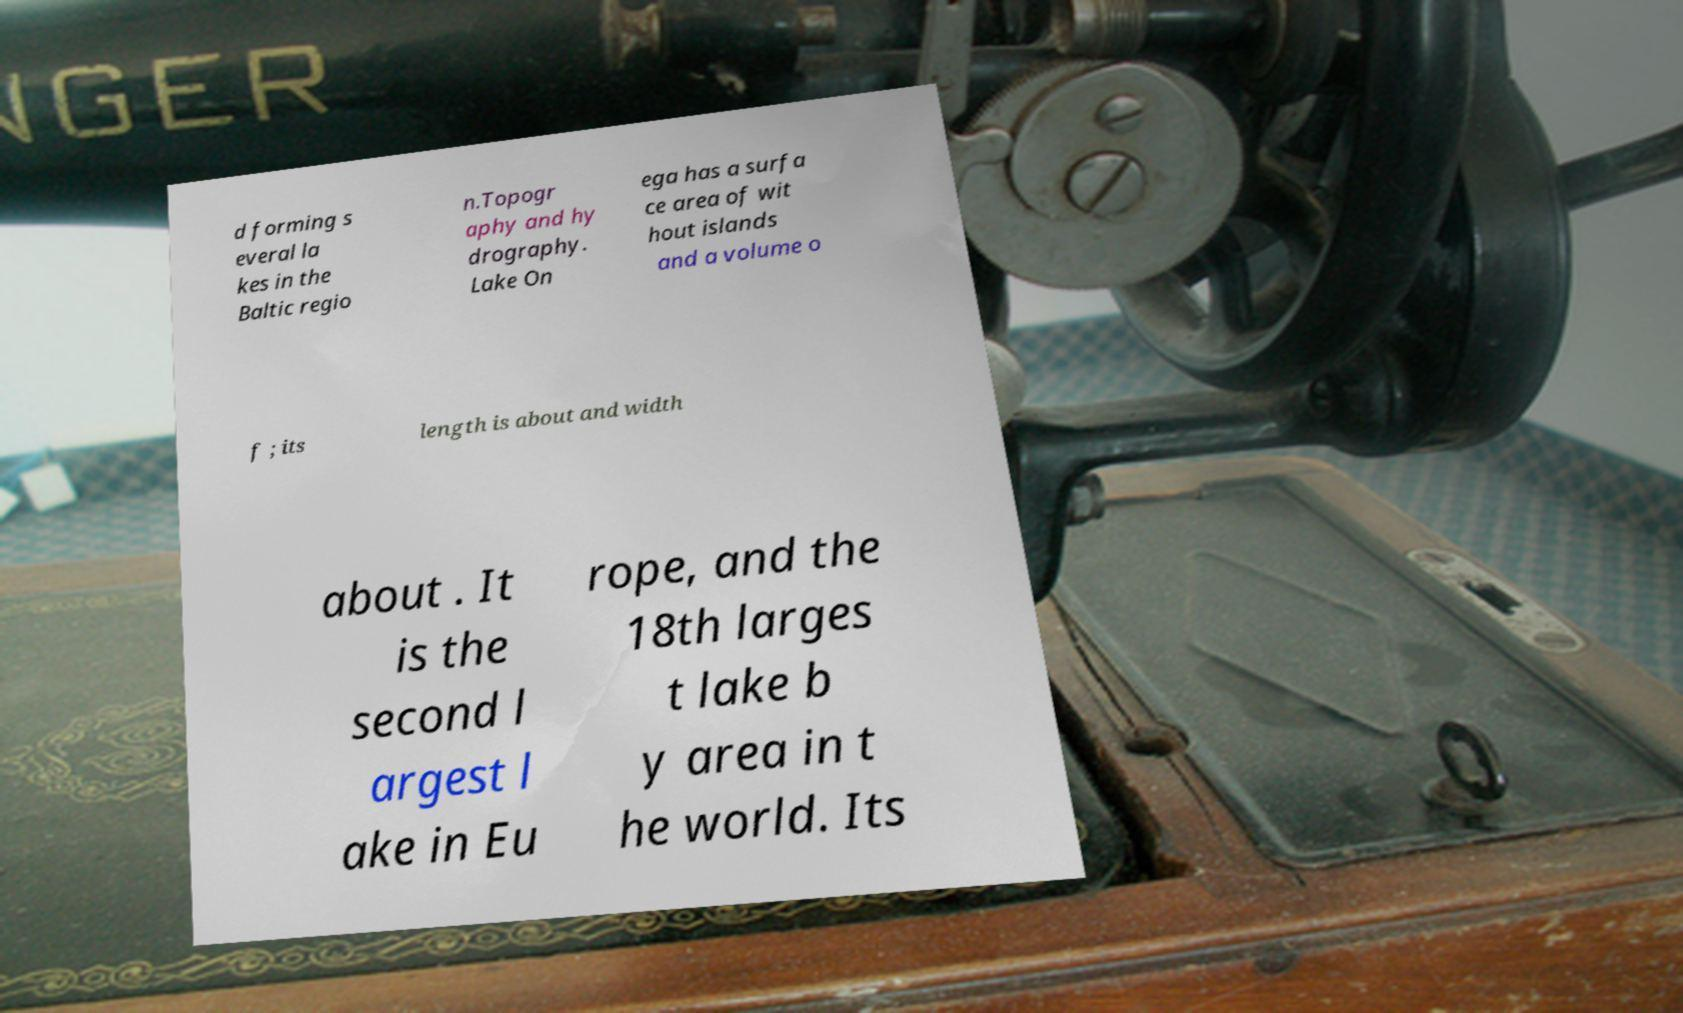Please identify and transcribe the text found in this image. d forming s everal la kes in the Baltic regio n.Topogr aphy and hy drography. Lake On ega has a surfa ce area of wit hout islands and a volume o f ; its length is about and width about . It is the second l argest l ake in Eu rope, and the 18th larges t lake b y area in t he world. Its 